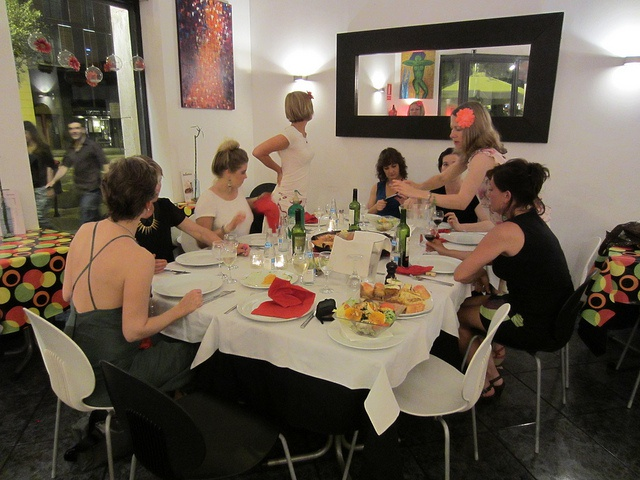Describe the objects in this image and their specific colors. I can see people in tan, black, and gray tones, people in tan, black, brown, and maroon tones, dining table in tan, gray, and black tones, chair in tan, black, and gray tones, and chair in tan, gray, darkgray, and black tones in this image. 